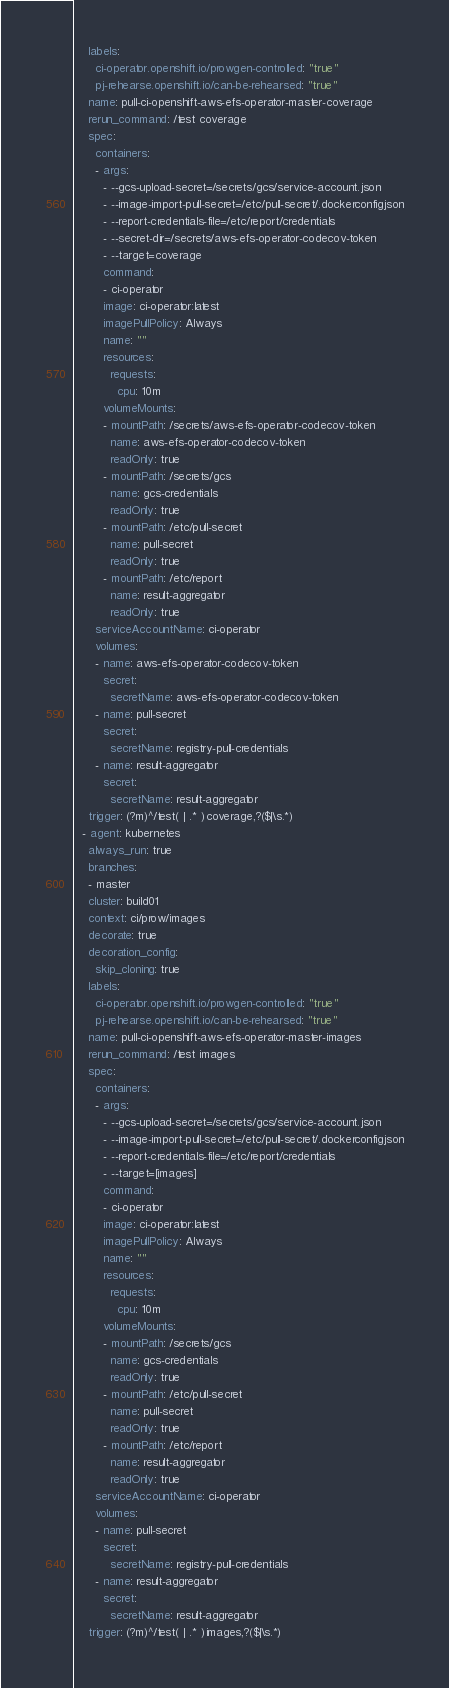<code> <loc_0><loc_0><loc_500><loc_500><_YAML_>    labels:
      ci-operator.openshift.io/prowgen-controlled: "true"
      pj-rehearse.openshift.io/can-be-rehearsed: "true"
    name: pull-ci-openshift-aws-efs-operator-master-coverage
    rerun_command: /test coverage
    spec:
      containers:
      - args:
        - --gcs-upload-secret=/secrets/gcs/service-account.json
        - --image-import-pull-secret=/etc/pull-secret/.dockerconfigjson
        - --report-credentials-file=/etc/report/credentials
        - --secret-dir=/secrets/aws-efs-operator-codecov-token
        - --target=coverage
        command:
        - ci-operator
        image: ci-operator:latest
        imagePullPolicy: Always
        name: ""
        resources:
          requests:
            cpu: 10m
        volumeMounts:
        - mountPath: /secrets/aws-efs-operator-codecov-token
          name: aws-efs-operator-codecov-token
          readOnly: true
        - mountPath: /secrets/gcs
          name: gcs-credentials
          readOnly: true
        - mountPath: /etc/pull-secret
          name: pull-secret
          readOnly: true
        - mountPath: /etc/report
          name: result-aggregator
          readOnly: true
      serviceAccountName: ci-operator
      volumes:
      - name: aws-efs-operator-codecov-token
        secret:
          secretName: aws-efs-operator-codecov-token
      - name: pull-secret
        secret:
          secretName: registry-pull-credentials
      - name: result-aggregator
        secret:
          secretName: result-aggregator
    trigger: (?m)^/test( | .* )coverage,?($|\s.*)
  - agent: kubernetes
    always_run: true
    branches:
    - master
    cluster: build01
    context: ci/prow/images
    decorate: true
    decoration_config:
      skip_cloning: true
    labels:
      ci-operator.openshift.io/prowgen-controlled: "true"
      pj-rehearse.openshift.io/can-be-rehearsed: "true"
    name: pull-ci-openshift-aws-efs-operator-master-images
    rerun_command: /test images
    spec:
      containers:
      - args:
        - --gcs-upload-secret=/secrets/gcs/service-account.json
        - --image-import-pull-secret=/etc/pull-secret/.dockerconfigjson
        - --report-credentials-file=/etc/report/credentials
        - --target=[images]
        command:
        - ci-operator
        image: ci-operator:latest
        imagePullPolicy: Always
        name: ""
        resources:
          requests:
            cpu: 10m
        volumeMounts:
        - mountPath: /secrets/gcs
          name: gcs-credentials
          readOnly: true
        - mountPath: /etc/pull-secret
          name: pull-secret
          readOnly: true
        - mountPath: /etc/report
          name: result-aggregator
          readOnly: true
      serviceAccountName: ci-operator
      volumes:
      - name: pull-secret
        secret:
          secretName: registry-pull-credentials
      - name: result-aggregator
        secret:
          secretName: result-aggregator
    trigger: (?m)^/test( | .* )images,?($|\s.*)
</code> 